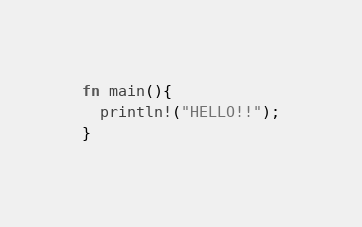Convert code to text. <code><loc_0><loc_0><loc_500><loc_500><_Rust_>fn main(){
  println!("HELLO!!");
}
</code> 